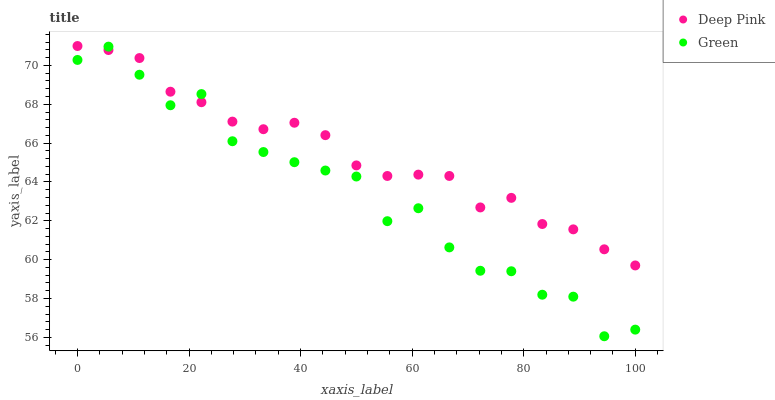Does Green have the minimum area under the curve?
Answer yes or no. Yes. Does Deep Pink have the maximum area under the curve?
Answer yes or no. Yes. Does Green have the maximum area under the curve?
Answer yes or no. No. Is Deep Pink the smoothest?
Answer yes or no. Yes. Is Green the roughest?
Answer yes or no. Yes. Is Green the smoothest?
Answer yes or no. No. Does Green have the lowest value?
Answer yes or no. Yes. Does Deep Pink have the highest value?
Answer yes or no. Yes. Does Green have the highest value?
Answer yes or no. No. Does Deep Pink intersect Green?
Answer yes or no. Yes. Is Deep Pink less than Green?
Answer yes or no. No. Is Deep Pink greater than Green?
Answer yes or no. No. 